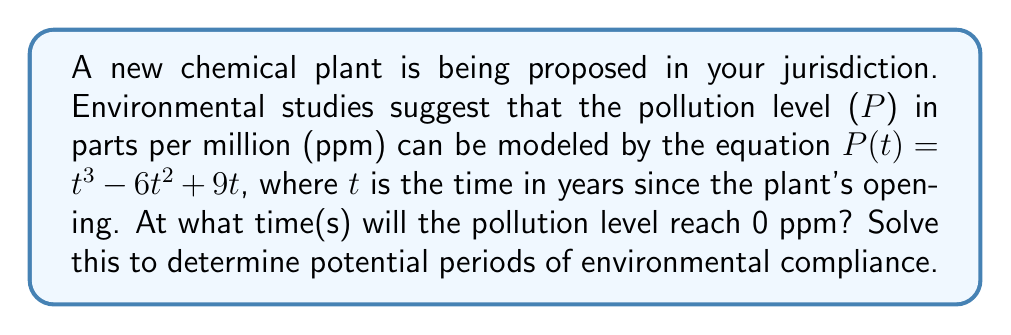Provide a solution to this math problem. To solve this problem, we need to find the roots of the polynomial equation:

$P(t) = t^3 - 6t^2 + 9t = 0$

Let's approach this step-by-step:

1) First, factor out the greatest common factor:
   $t(t^2 - 6t + 9) = 0$

2) We can see that $t = 0$ is one solution. For the other factor, we can use the quadratic formula or recognize it as a perfect square trinomial.

3) $t^2 - 6t + 9$ can be rewritten as $(t - 3)^2$

4) So our equation becomes:
   $t(t - 3)^2 = 0$

5) The solutions to this equation are:
   $t = 0$ or $t - 3 = 0$

6) Solving the second equation:
   $t = 3$

Therefore, the pollution level will reach 0 ppm at $t = 0$ and $t = 3$ years after the plant's opening.

The solution $t = 0$ indicates that the pollution level starts at 0 when the plant opens. The solution $t = 3$ suggests that the pollution level will return to 0 after 3 years, potentially due to implemented environmental controls or natural processes.
Answer: $t = 0$ and $t = 3$ years 